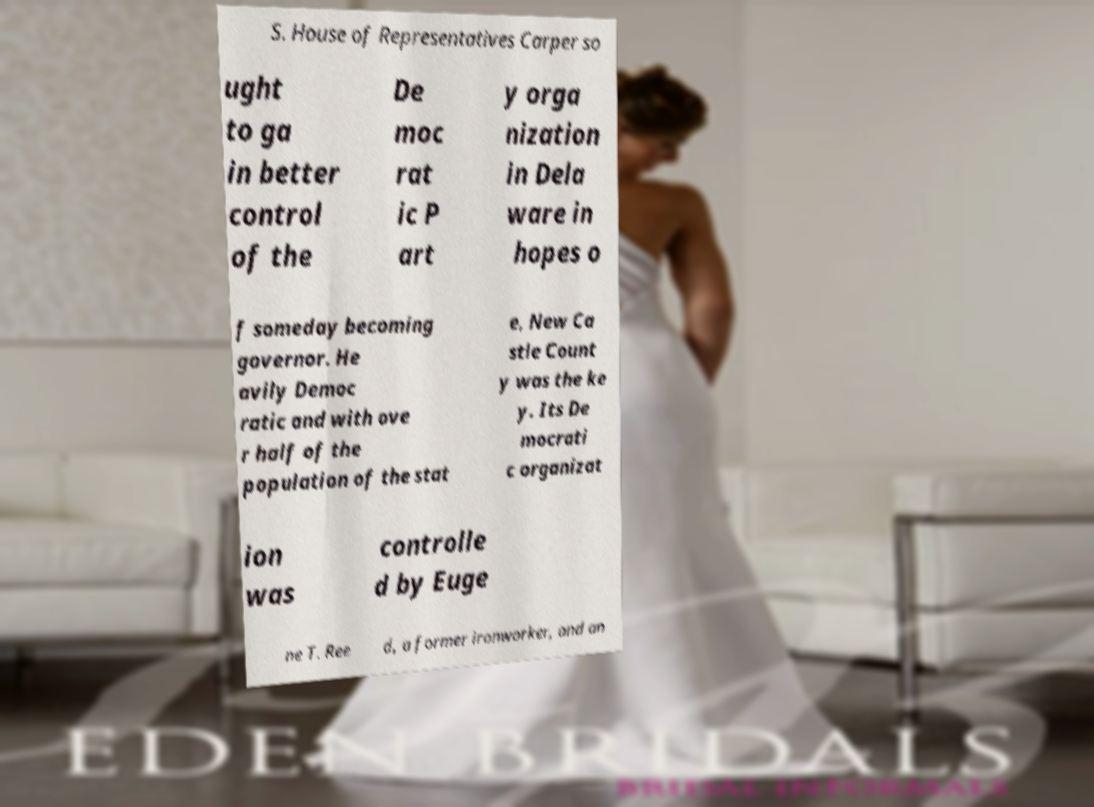Could you assist in decoding the text presented in this image and type it out clearly? S. House of Representatives Carper so ught to ga in better control of the De moc rat ic P art y orga nization in Dela ware in hopes o f someday becoming governor. He avily Democ ratic and with ove r half of the population of the stat e, New Ca stle Count y was the ke y. Its De mocrati c organizat ion was controlle d by Euge ne T. Ree d, a former ironworker, and an 